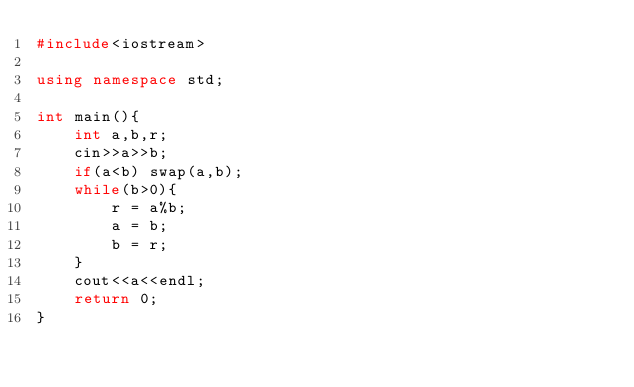Convert code to text. <code><loc_0><loc_0><loc_500><loc_500><_C++_>#include<iostream>

using namespace std;

int main(){
    int a,b,r;
    cin>>a>>b;
    if(a<b) swap(a,b);
    while(b>0){
        r = a%b;
        a = b;
        b = r;
    }
    cout<<a<<endl;
    return 0;
}
</code> 